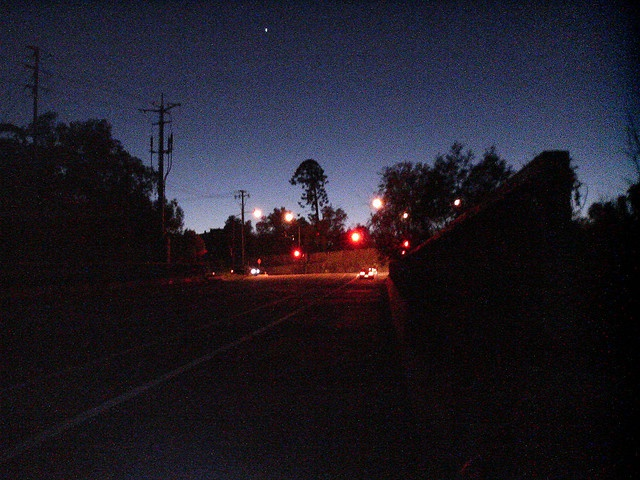Describe the objects in this image and their specific colors. I can see traffic light in black, red, salmon, ivory, and orange tones, car in black, ivory, brown, maroon, and salmon tones, traffic light in black, maroon, brown, and red tones, car in black, white, brown, maroon, and purple tones, and traffic light in black, red, ivory, brown, and salmon tones in this image. 